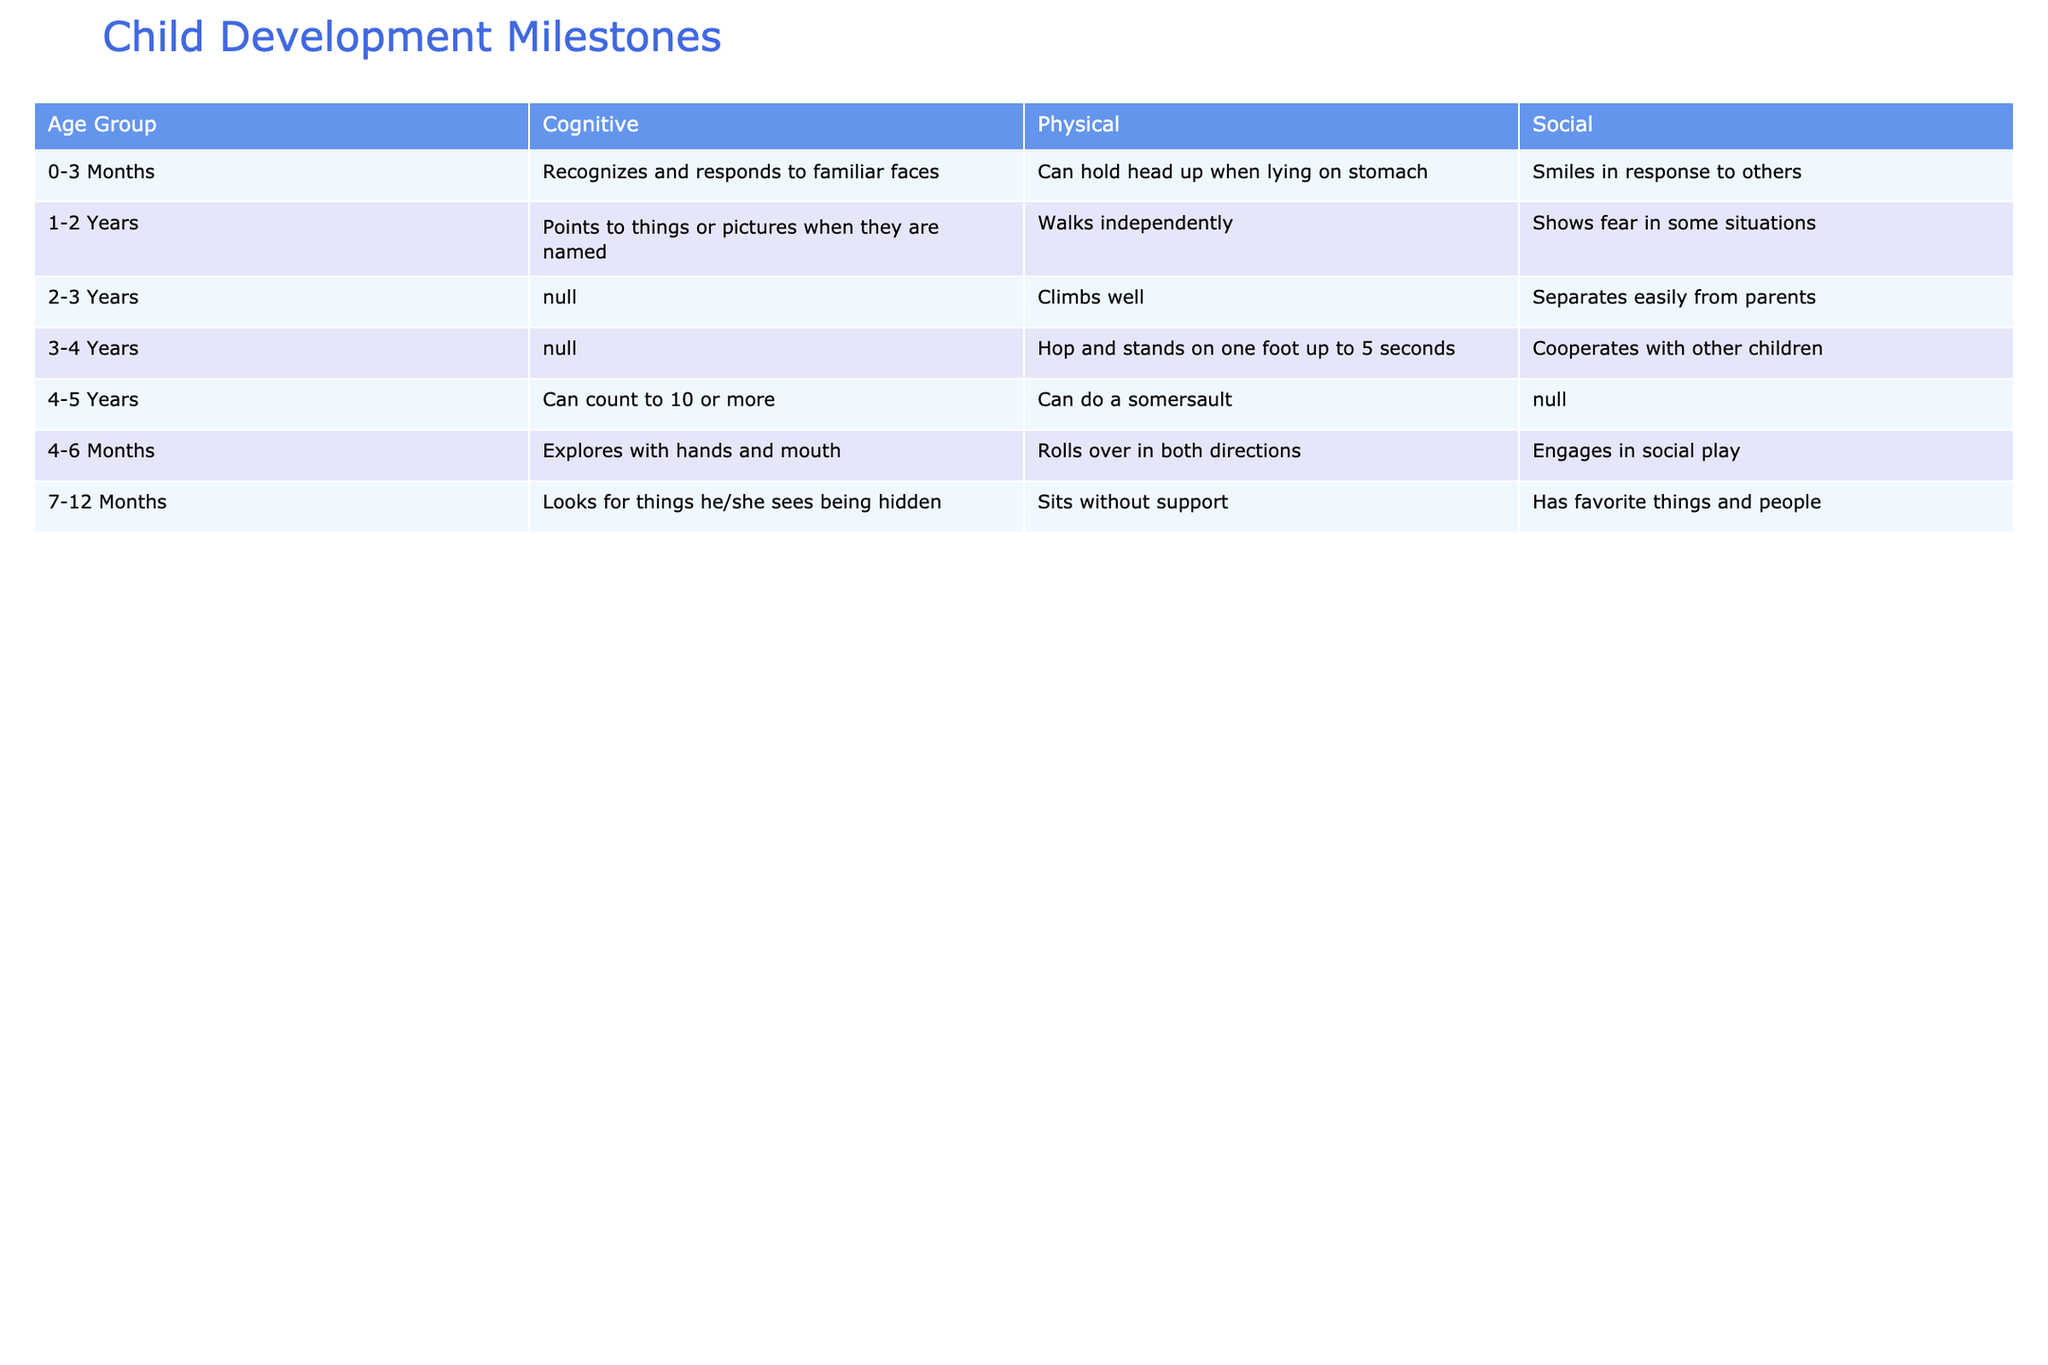What milestones are listed for the 0-3 Months age group? The table lists three milestones for the 0-3 Months age group: "Can hold head up when lying on stomach" under Physical, "Recognizes and responds to familiar faces" under Cognitive, and "Smiles in response to others" under Social.
Answer: Three milestones Which age group is associated with the milestone "Climbs well"? The milestone "Climbs well" is associated with the 2-3 Years age group as indicated in the table.
Answer: 2-3 Years Is there a cognitive milestone for the 1-2 Years age group? Yes, the table shows that the cognitive milestone for the 1-2 Years age group is "Points to things or pictures when they are named." Thus, the answer is true.
Answer: Yes How many physical milestones are listed in total? The physical milestones are as follows: "Can hold head up when lying on stomach" (0-3 Months), "Rolls over in both directions" (4-6 Months), "Sits without support" (7-12 Months), "Walks independently" (1-2 Years), "Climbs well" (2-3 Years), and "Hop and stands on one foot up to 5 seconds" (3-4 Years), and "Can do a somersault" (4-5 Years). There are 7 in total.
Answer: 7 What is the difference between the number of social milestones for 4-5 Years and 0-3 Months age groups? The social milestones are "Smiles in response to others" for 0-3 Months and "Cooperates with other children" for 4-5 Years. The 0-3 Months age group has 1 social milestone, while the 4-5 Years age group has 1 social milestone. Thus, the difference is 1 - 1 = 0.
Answer: 0 What is the longest age group duration with milestones listed? The age groups are: 0-3 Months, 4-6 Months, 7-12 Months, 1-2 Years, 2-3 Years, 3-4 Years, and 4-5 Years. The longest duration is seen in the "7-12 Months" age group, where there are distinct milestones listed compared to others. This age group is usually referred to as months and contains a precise duration for milestones.
Answer: 7-12 Months Do both "Sits without support" and "Climbs well" belong to the same cognitive domain? No, "Sits without support" is a physical milestone in the 7-12 Months age group, while "Climbs well" is a physical milestone in the 2-3 Years age group. Therefore, they do not belong to the same domain.
Answer: No 